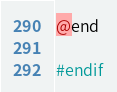Convert code to text. <code><loc_0><loc_0><loc_500><loc_500><_C_>@end

#endif
</code> 